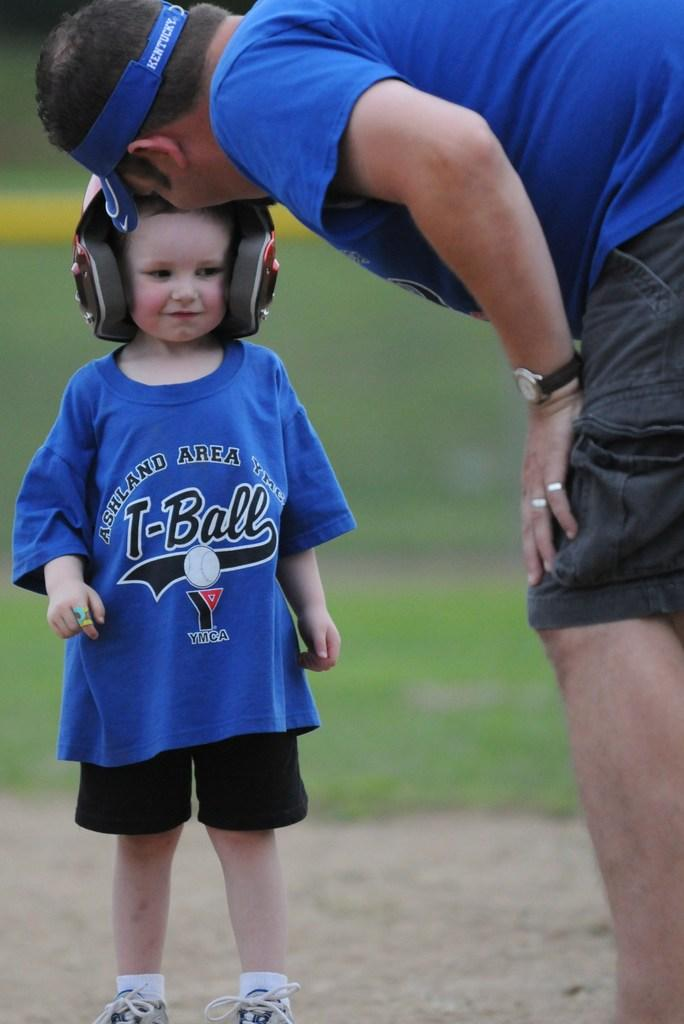<image>
Give a short and clear explanation of the subsequent image. man talking to child wearing an ashland area ymca t-ball shirt 